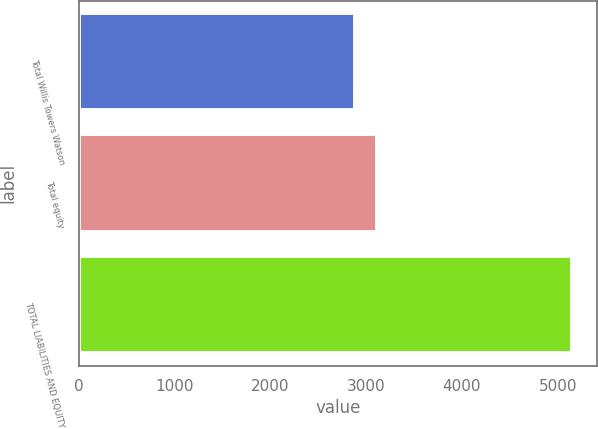<chart> <loc_0><loc_0><loc_500><loc_500><bar_chart><fcel>Total Willis Towers Watson<fcel>Total equity<fcel>TOTAL LIABILITIES AND EQUITY<nl><fcel>2886<fcel>3112.3<fcel>5149<nl></chart> 